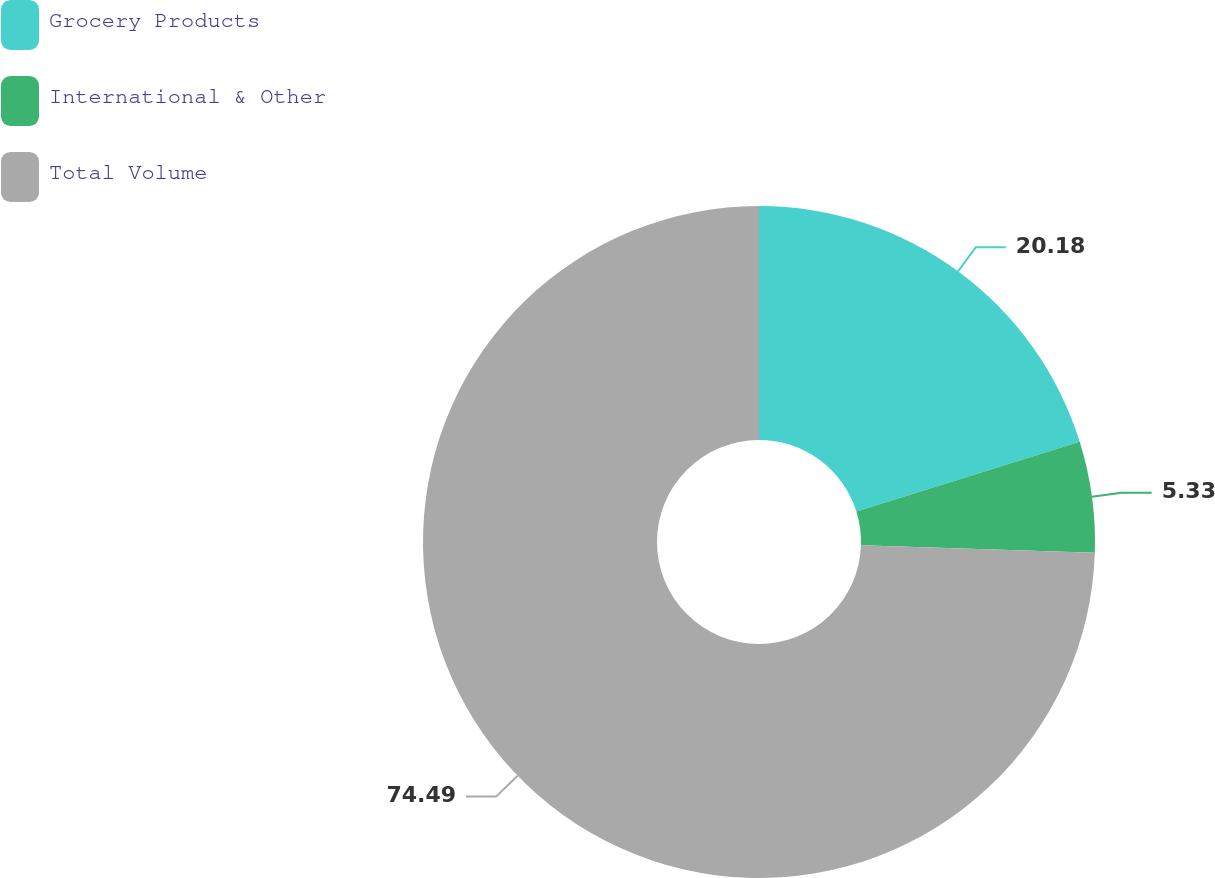Convert chart. <chart><loc_0><loc_0><loc_500><loc_500><pie_chart><fcel>Grocery Products<fcel>International & Other<fcel>Total Volume<nl><fcel>20.18%<fcel>5.33%<fcel>74.48%<nl></chart> 